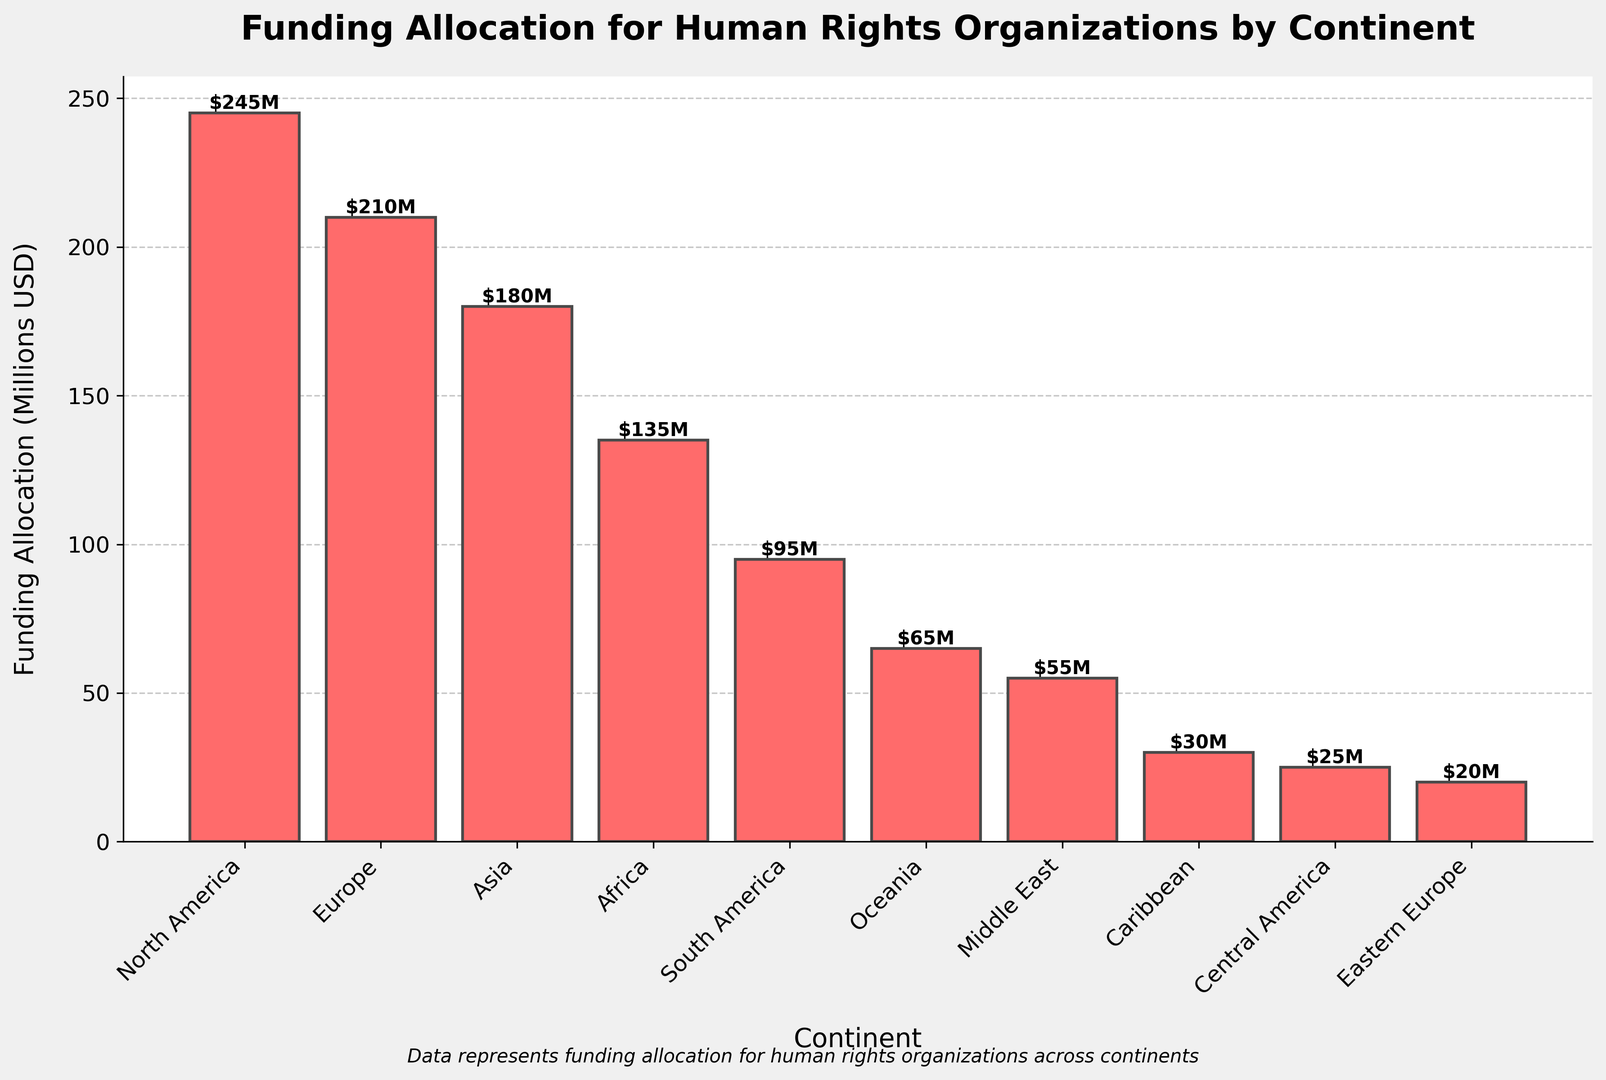What's the total funding allocation across all continents? Add up the funding allocations for all continents: 245 + 210 + 180 + 135 + 95 + 65 + 55 + 30 + 25 + 20 = 1060 (Millions USD)
Answer: 1060M Which continent received the highest funding allocation? Identify the continent with the highest bar in the plot, which represents North America with a funding allocation of 245M USD.
Answer: North America What is the difference in funding between North America and Europe? Subtract the funding for Europe from North America: 245 - 210 = 35 (Millions USD)
Answer: 35M How much more funding does Asia receive compared to Africa? Subtract the funding for Africa from Asia: 180 - 135 = 45 (Millions USD)
Answer: 45M Which continent has the lowest funding allocation? Identify the continent with the smallest bar, which represents Eastern Europe with a funding allocation of 20M USD.
Answer: Eastern Europe What's the average funding allocation for continents with funding above 100M USD? Identify continents with funding above 100M USD (North America, Europe, Asia, Africa). Sum their funding: 245 + 210 + 180 + 135 = 770, then divide by the number of these continents (4): 770/4 = 192.5 (Millions USD)
Answer: 192.5M How many continents have a funding allocation less than 100M USD? Count the number of bars representing continents with funding less than 100M USD (South America, Oceania, Middle East, Caribbean, Central America, Eastern Europe). There are 6 continents with funding < 100M.
Answer: 6 What is the median funding allocation? Arrange the funding allocations in ascending order (20, 25, 30, 55, 65, 95, 135, 180, 210, 245). The middle value of 10 data points is the average of the 5th and 6th values: (65 + 95)/2 = 80 (Millions USD)
Answer: 80M Which two continents combined have a funding allocation of 150M USD? Identify combinations of two continents’ funding that sum to 150M USD. Africa (135M) combined with either Central America (25M) or Eastern Europe (20M) approximately fits this requirement. Hence, both combinations: Africa + Caribbean
Answer: Africa + Caribbean 